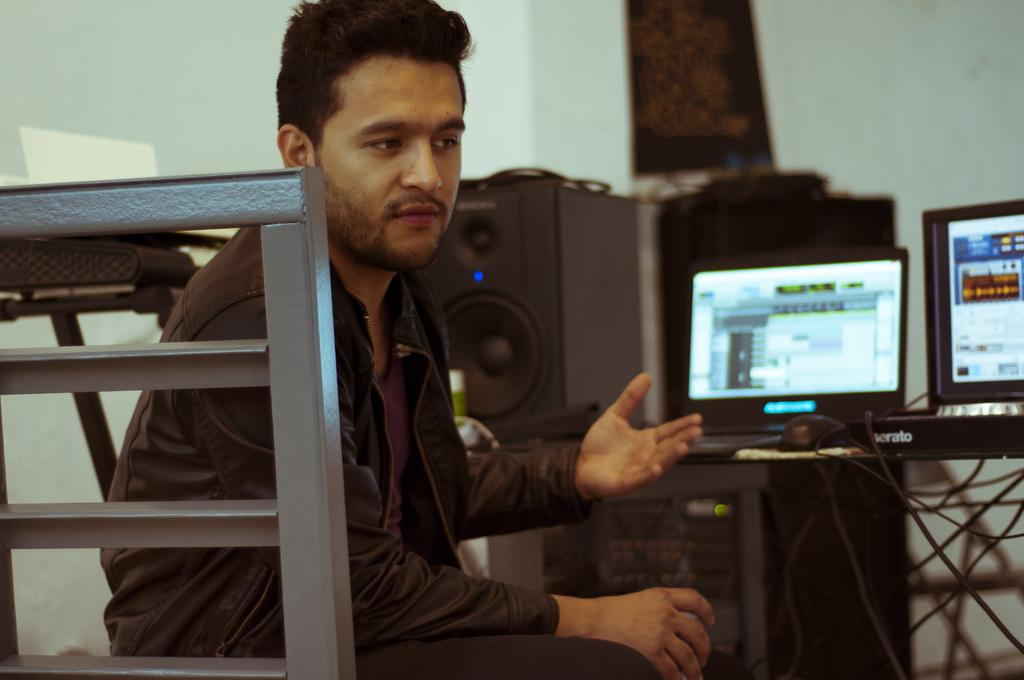Who is in the image? There is a person in the image. What is the person wearing? The person is wearing a black dress. What type of object can be seen in the image? There is a metal object in the image. What can be seen in the background of the image? There are speakers, wires, monitors, and other objects in the background of the image. There is also a wall in the background. What type of bag is being exchanged between the person and the snow in the image? There is no bag or snow present in the image. 